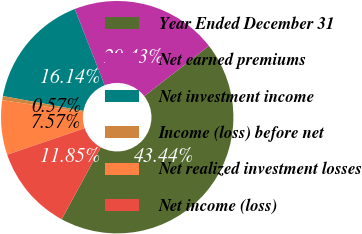Convert chart. <chart><loc_0><loc_0><loc_500><loc_500><pie_chart><fcel>Year Ended December 31<fcel>Net earned premiums<fcel>Net investment income<fcel>Income (loss) before net<fcel>Net realized investment losses<fcel>Net income (loss)<nl><fcel>43.44%<fcel>20.43%<fcel>16.14%<fcel>0.57%<fcel>7.57%<fcel>11.85%<nl></chart> 